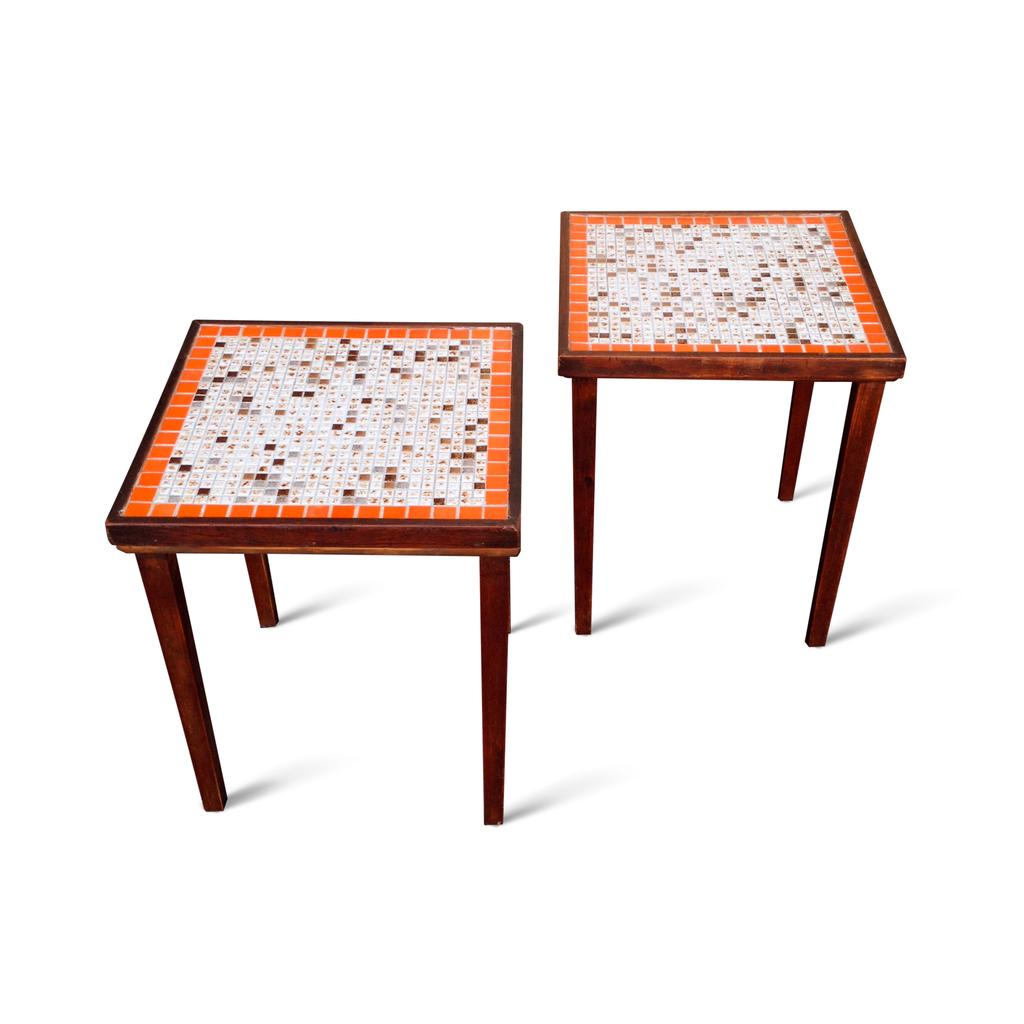How many tables can be seen in the image? There are two tables in the image. What can be observed in the background of the image? The background of the image is white in color. What type of brass instrument is being played in the image? There is no brass instrument present in the image; the provided facts only mention the presence of two tables and a white background. 